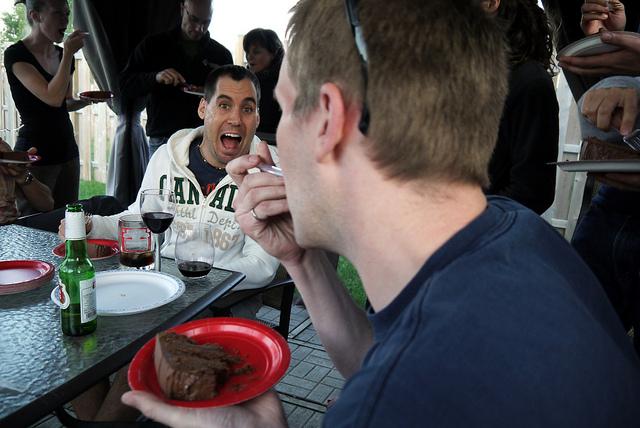What is on top of his head?
Short answer required. Glasses. Are both guys drinking beer?
Give a very brief answer. No. Is this a party?
Keep it brief. Yes. What is the table made of?
Answer briefly. Glass. 